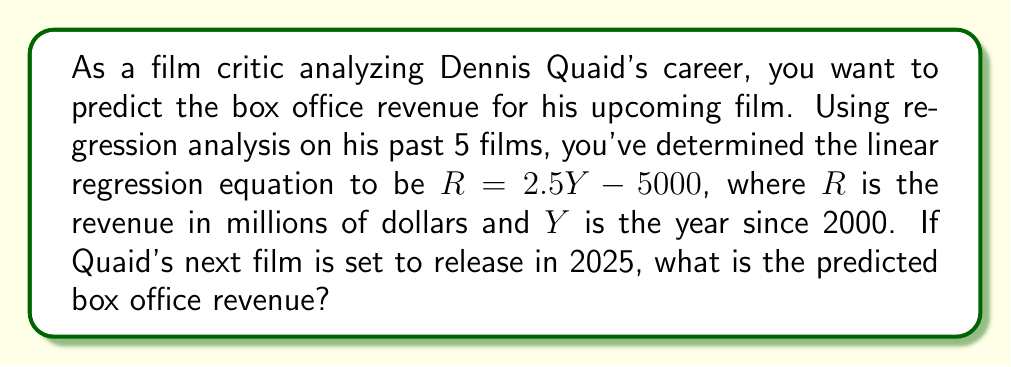Solve this math problem. To solve this problem, we'll follow these steps:

1. Identify the given information:
   - Linear regression equation: $R = 2.5Y - 5000$
   - $R$ is the revenue in millions of dollars
   - $Y$ is the year since 2000
   - The film will be released in 2025

2. Calculate $Y$ for 2025:
   $Y = 2025 - 2000 = 25$

3. Substitute $Y = 25$ into the regression equation:
   $R = 2.5Y - 5000$
   $R = 2.5(25) - 5000$

4. Solve for $R$:
   $R = 62.5 - 5000$
   $R = -4937.5$

5. Interpret the result:
   The predicted box office revenue is -$4937.5 million, which is not realistic for a movie.

6. Explain the limitation:
   This negative result indicates that the linear regression model might not be appropriate for long-term predictions or that there are other factors influencing box office revenue not captured by this simple model.
Answer: $-4937.5$ million (unrealistic prediction, suggesting model limitations) 